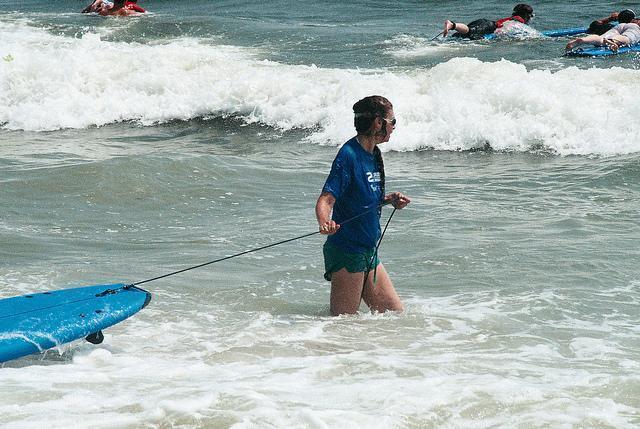What are surfboards made out of?
Pick the right solution, then justify: 'Answer: answer
Rationale: rationale.'
Options: Foam, rubber, cloth, wood. Answer: rubber.
Rationale: The material helps the surf board float 